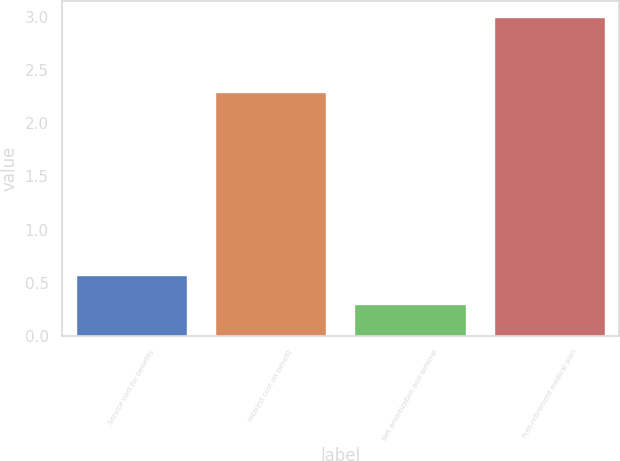Convert chart to OTSL. <chart><loc_0><loc_0><loc_500><loc_500><bar_chart><fcel>Service cost for benefits<fcel>Interest cost on benefit<fcel>Net amortization and deferral<fcel>Post-retirement medical plan<nl><fcel>0.57<fcel>2.3<fcel>0.3<fcel>3<nl></chart> 